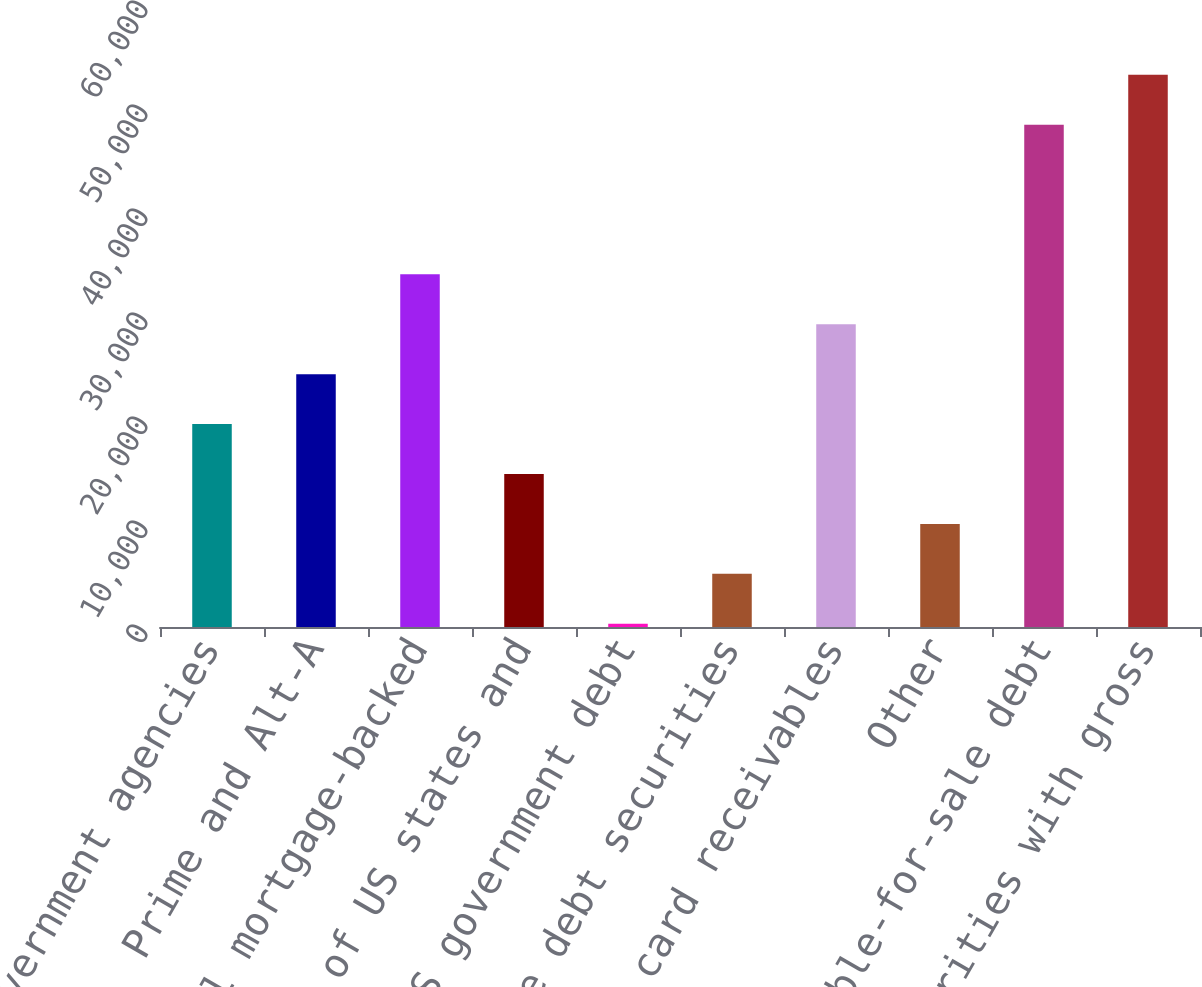Convert chart to OTSL. <chart><loc_0><loc_0><loc_500><loc_500><bar_chart><fcel>US government agencies<fcel>Prime and Alt-A<fcel>Total mortgage-backed<fcel>Obligations of US states and<fcel>Non-US government debt<fcel>Corporate debt securities<fcel>Credit card receivables<fcel>Other<fcel>Total available-for-sale debt<fcel>Total securities with gross<nl><fcel>19509.2<fcel>24309.5<fcel>33910.1<fcel>14708.9<fcel>308<fcel>5108.3<fcel>29109.8<fcel>9908.6<fcel>48292<fcel>53092.3<nl></chart> 